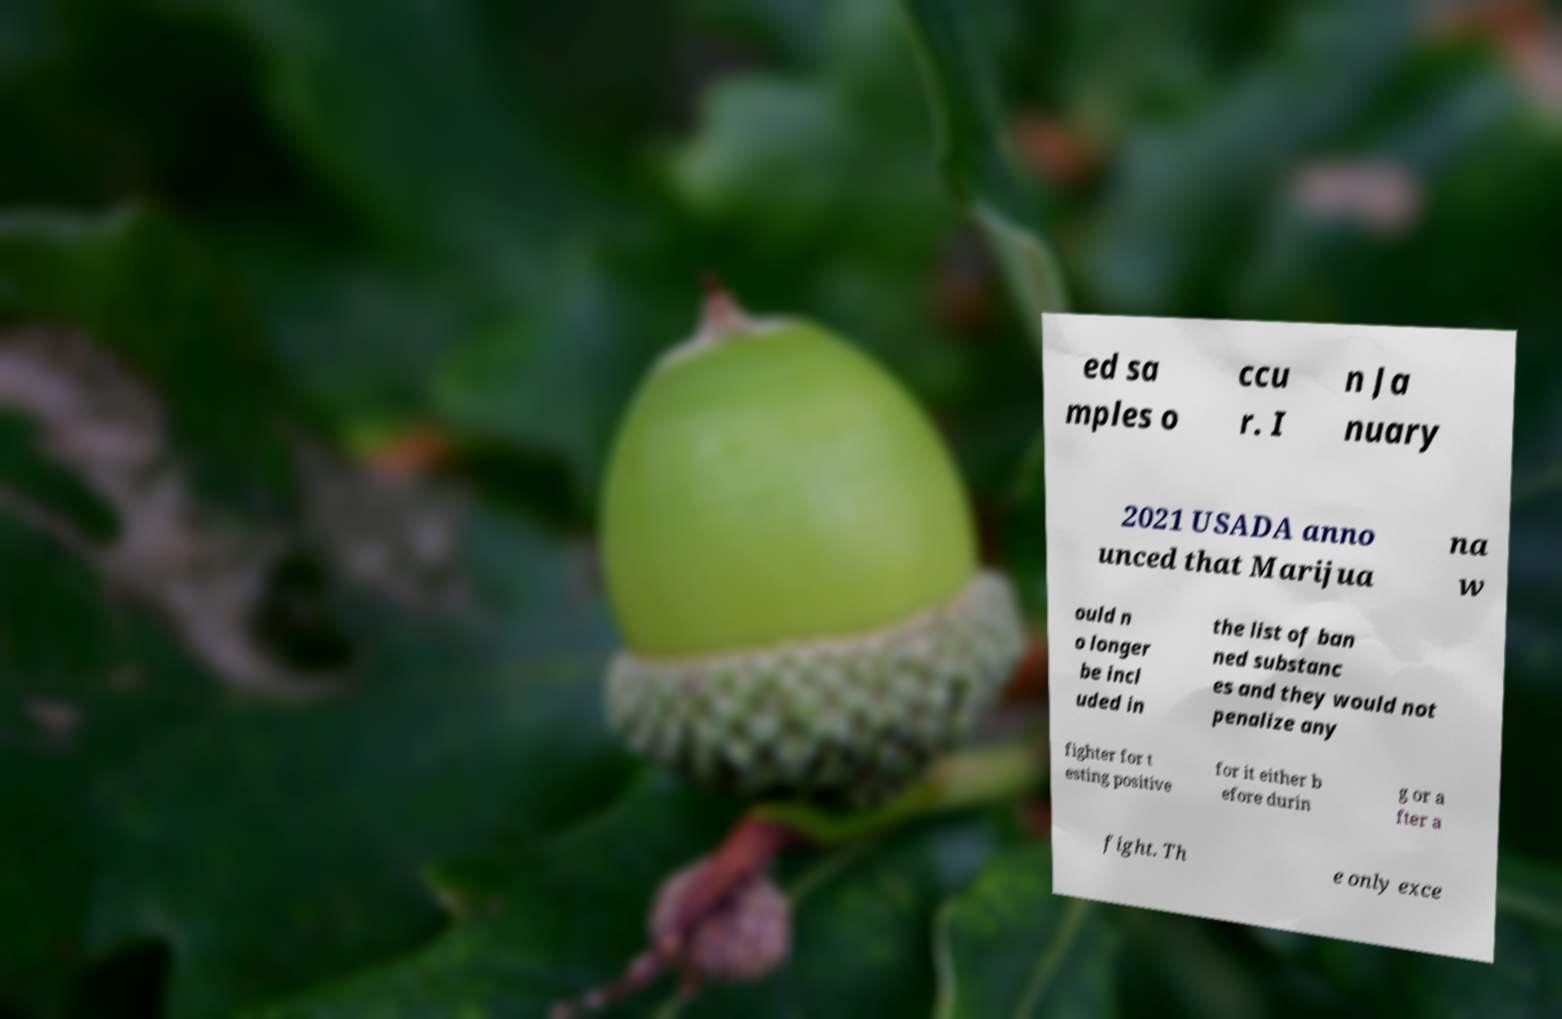Could you assist in decoding the text presented in this image and type it out clearly? ed sa mples o ccu r. I n Ja nuary 2021 USADA anno unced that Marijua na w ould n o longer be incl uded in the list of ban ned substanc es and they would not penalize any fighter for t esting positive for it either b efore durin g or a fter a fight. Th e only exce 